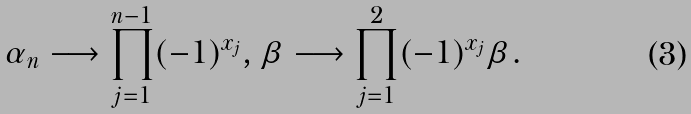Convert formula to latex. <formula><loc_0><loc_0><loc_500><loc_500>\alpha _ { n } \longrightarrow \prod _ { j = 1 } ^ { n - 1 } ( - 1 ) ^ { x _ { j } } , \beta \longrightarrow \prod _ { j = 1 } ^ { 2 } ( - 1 ) ^ { x _ { j } } \beta .</formula> 